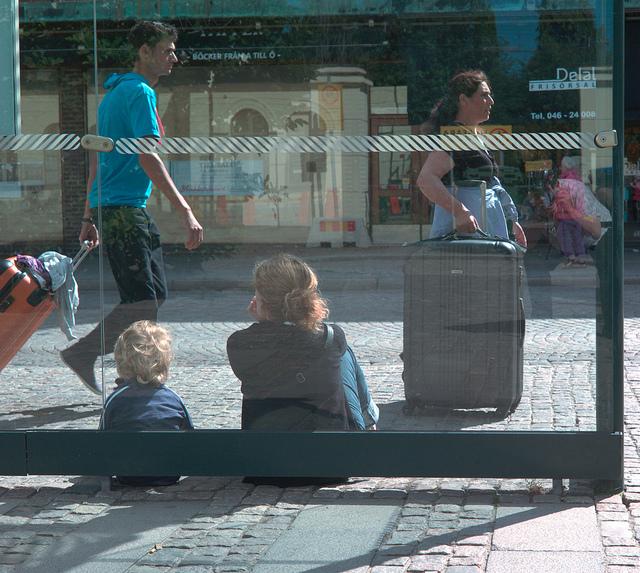How many children are on the sidewalk?
Quick response, please. 2. Does the woman on the right have a small carry-on bag?
Keep it brief. No. What are they waiting on?
Write a very short answer. Bus. 